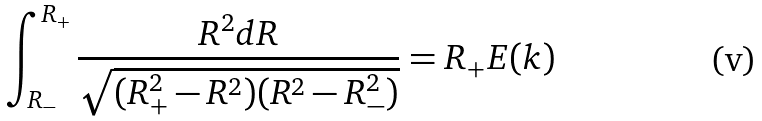Convert formula to latex. <formula><loc_0><loc_0><loc_500><loc_500>\int _ { R _ { - } } ^ { R _ { + } } \frac { R ^ { 2 } d R } { \sqrt { ( R _ { + } ^ { 2 } - R ^ { 2 } ) ( R ^ { 2 } - R _ { - } ^ { 2 } ) } } = R _ { + } E ( k )</formula> 